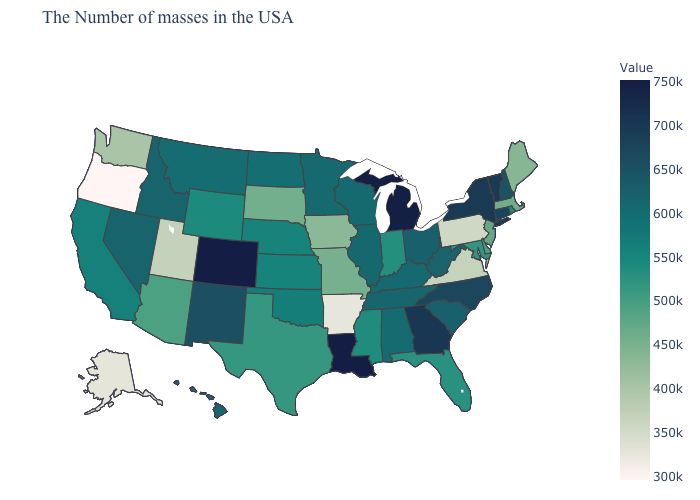Does Alaska have the lowest value in the USA?
Quick response, please. No. Is the legend a continuous bar?
Be succinct. Yes. Which states have the highest value in the USA?
Give a very brief answer. Louisiana, Colorado. Does Ohio have a higher value than Colorado?
Concise answer only. No. Which states have the highest value in the USA?
Short answer required. Louisiana, Colorado. Among the states that border Nebraska , does Colorado have the highest value?
Answer briefly. Yes. Which states have the lowest value in the USA?
Keep it brief. Oregon. Does South Carolina have the lowest value in the USA?
Keep it brief. No. 